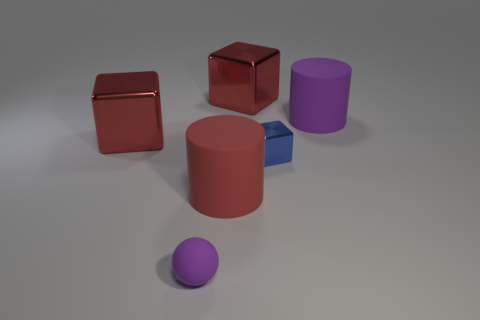Does the thing to the right of the blue block have the same material as the blue object?
Your response must be concise. No. The red rubber thing that is the same size as the purple cylinder is what shape?
Your answer should be compact. Cylinder. How many big objects are the same color as the tiny matte ball?
Give a very brief answer. 1. Are there fewer small purple rubber balls that are in front of the tiny blue shiny block than large objects that are to the left of the big purple cylinder?
Keep it short and to the point. Yes. There is a big red matte cylinder; are there any large red objects to the right of it?
Keep it short and to the point. Yes. Is there a red matte object to the right of the red object that is to the left of the purple object left of the small metallic thing?
Ensure brevity in your answer.  Yes. Do the big rubber object that is on the left side of the purple cylinder and the large purple rubber thing have the same shape?
Offer a very short reply. Yes. There is a big object that is made of the same material as the red cylinder; what color is it?
Offer a terse response. Purple. How many blue things are made of the same material as the tiny purple ball?
Provide a short and direct response. 0. There is a matte cylinder that is to the left of the cube that is in front of the red shiny block that is left of the purple ball; what is its color?
Your answer should be very brief. Red. 